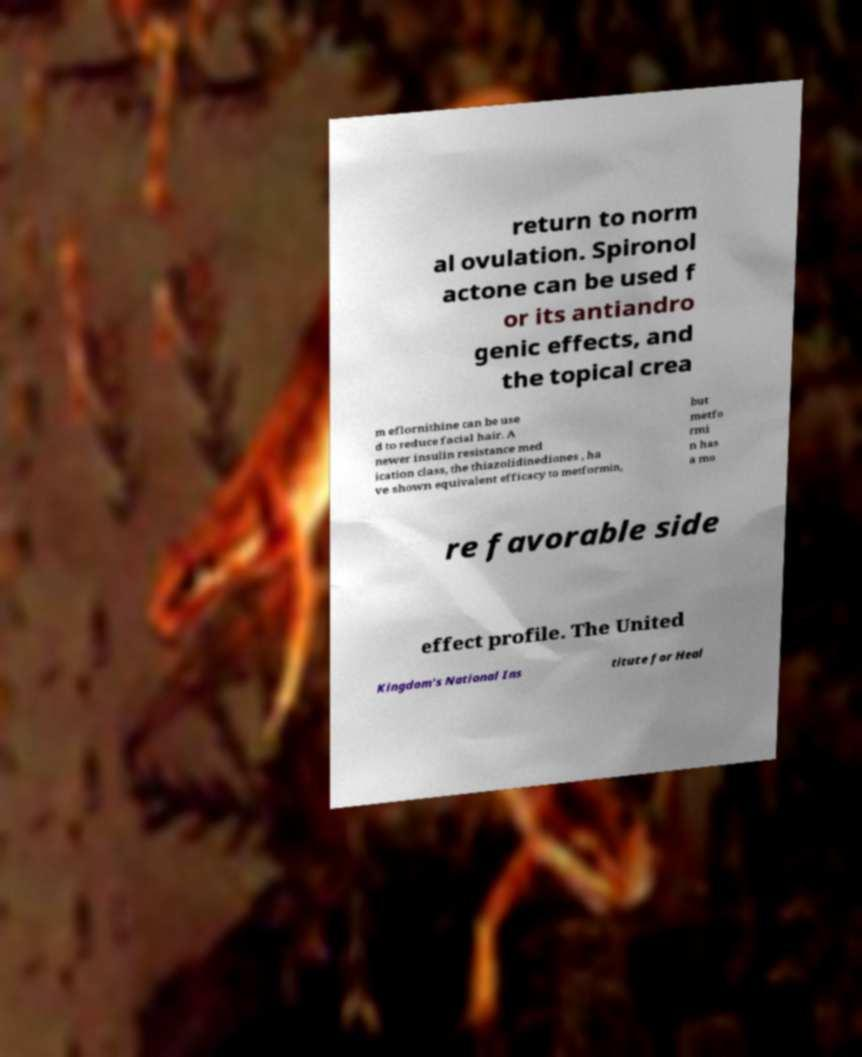Could you assist in decoding the text presented in this image and type it out clearly? return to norm al ovulation. Spironol actone can be used f or its antiandro genic effects, and the topical crea m eflornithine can be use d to reduce facial hair. A newer insulin resistance med ication class, the thiazolidinediones , ha ve shown equivalent efficacy to metformin, but metfo rmi n has a mo re favorable side effect profile. The United Kingdom's National Ins titute for Heal 